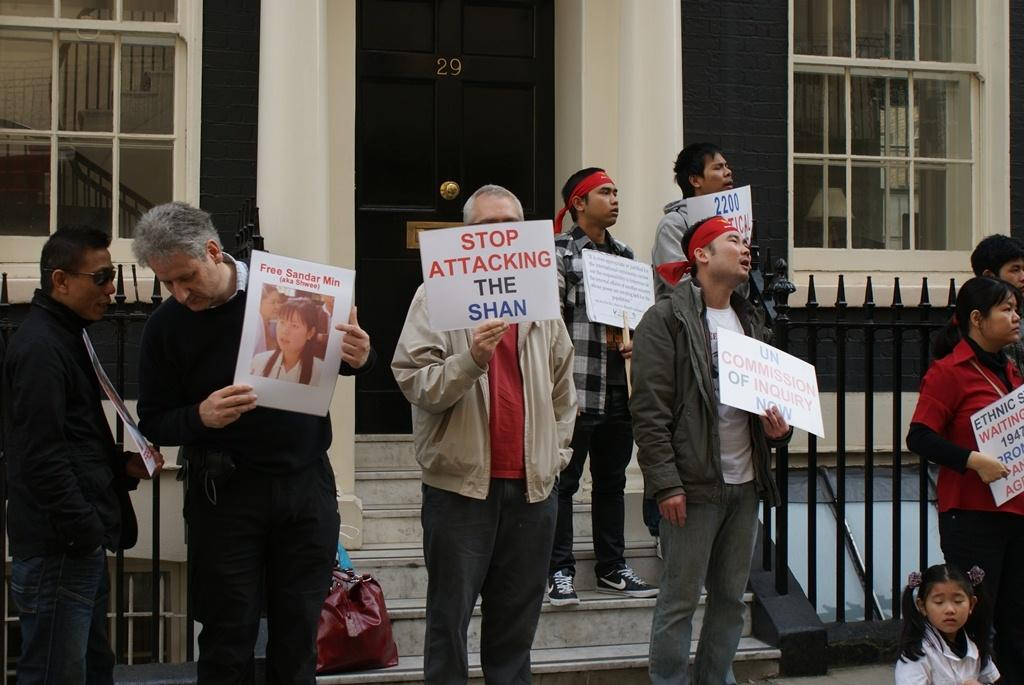What are the people in the image doing? The people in the image are standing and holding placards in their hands. Where are the people standing in the image? The people are standing on the floor and on the stairs. What can be seen in the background of the image? There are buildings and grills visible in the background of the image. What is the income of the person standing on the stairs in the image? There is no information about the income of the person standing on the stairs in the image. What shape are the grills visible in the background of the image? The shape of the grills cannot be determined from the image. 